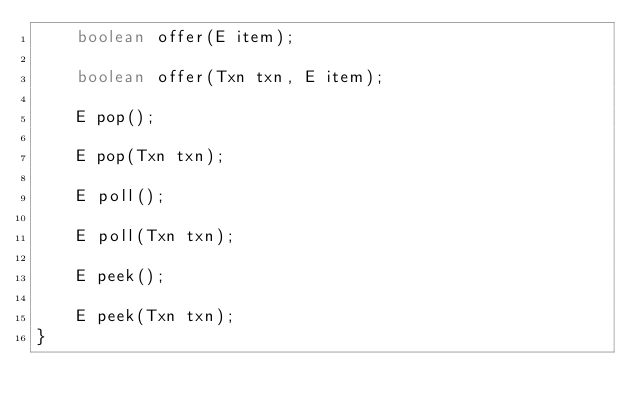<code> <loc_0><loc_0><loc_500><loc_500><_Java_>    boolean offer(E item);

    boolean offer(Txn txn, E item);

    E pop();

    E pop(Txn txn);

    E poll();

    E poll(Txn txn);

    E peek();

    E peek(Txn txn);
}
</code> 